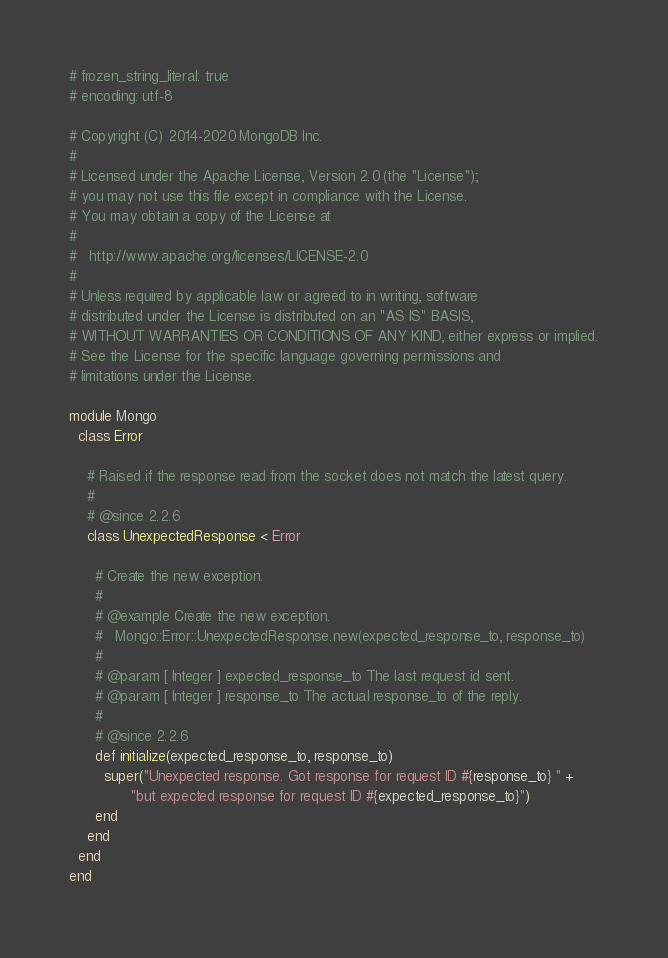Convert code to text. <code><loc_0><loc_0><loc_500><loc_500><_Ruby_># frozen_string_literal: true
# encoding: utf-8

# Copyright (C) 2014-2020 MongoDB Inc.
#
# Licensed under the Apache License, Version 2.0 (the "License");
# you may not use this file except in compliance with the License.
# You may obtain a copy of the License at
#
#   http://www.apache.org/licenses/LICENSE-2.0
#
# Unless required by applicable law or agreed to in writing, software
# distributed under the License is distributed on an "AS IS" BASIS,
# WITHOUT WARRANTIES OR CONDITIONS OF ANY KIND, either express or implied.
# See the License for the specific language governing permissions and
# limitations under the License.

module Mongo
  class Error

    # Raised if the response read from the socket does not match the latest query.
    #
    # @since 2.2.6
    class UnexpectedResponse < Error

      # Create the new exception.
      #
      # @example Create the new exception.
      #   Mongo::Error::UnexpectedResponse.new(expected_response_to, response_to)
      #
      # @param [ Integer ] expected_response_to The last request id sent.
      # @param [ Integer ] response_to The actual response_to of the reply.
      #
      # @since 2.2.6
      def initialize(expected_response_to, response_to)
        super("Unexpected response. Got response for request ID #{response_to} " +
              "but expected response for request ID #{expected_response_to}")
      end
    end
  end
end
</code> 